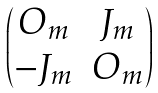Convert formula to latex. <formula><loc_0><loc_0><loc_500><loc_500>\begin{pmatrix} O _ { m } & J _ { m } \\ - J _ { m } & O _ { m } \end{pmatrix}</formula> 